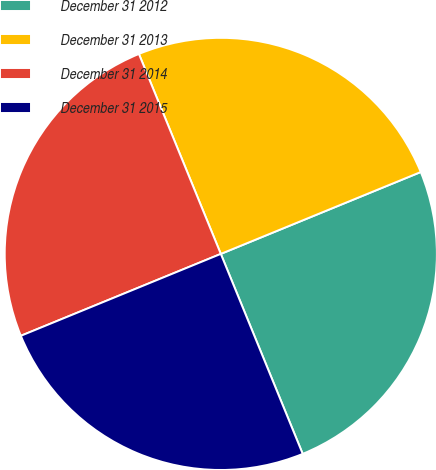<chart> <loc_0><loc_0><loc_500><loc_500><pie_chart><fcel>December 31 2012<fcel>December 31 2013<fcel>December 31 2014<fcel>December 31 2015<nl><fcel>25.0%<fcel>25.0%<fcel>25.0%<fcel>25.0%<nl></chart> 